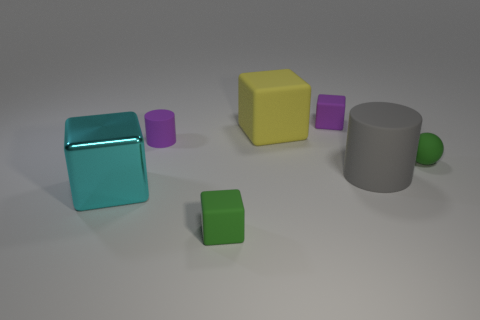How many other blocks are made of the same material as the yellow cube?
Your response must be concise. 2. How many spheres are either large red metal objects or large rubber objects?
Provide a succinct answer. 0. What size is the green thing to the left of the green object that is behind the small matte cube in front of the cyan thing?
Ensure brevity in your answer.  Small. There is a tiny matte thing that is both in front of the purple cylinder and behind the gray rubber cylinder; what color is it?
Provide a succinct answer. Green. There is a yellow cube; is it the same size as the green block in front of the metallic block?
Give a very brief answer. No. Is there anything else that is the same shape as the large yellow object?
Provide a short and direct response. Yes. There is a big rubber thing that is the same shape as the metal object; what color is it?
Your answer should be very brief. Yellow. Do the yellow object and the rubber ball have the same size?
Make the answer very short. No. How many other things are the same size as the green block?
Make the answer very short. 3. How many things are green rubber objects on the right side of the gray cylinder or small rubber objects that are behind the big cyan thing?
Keep it short and to the point. 3. 